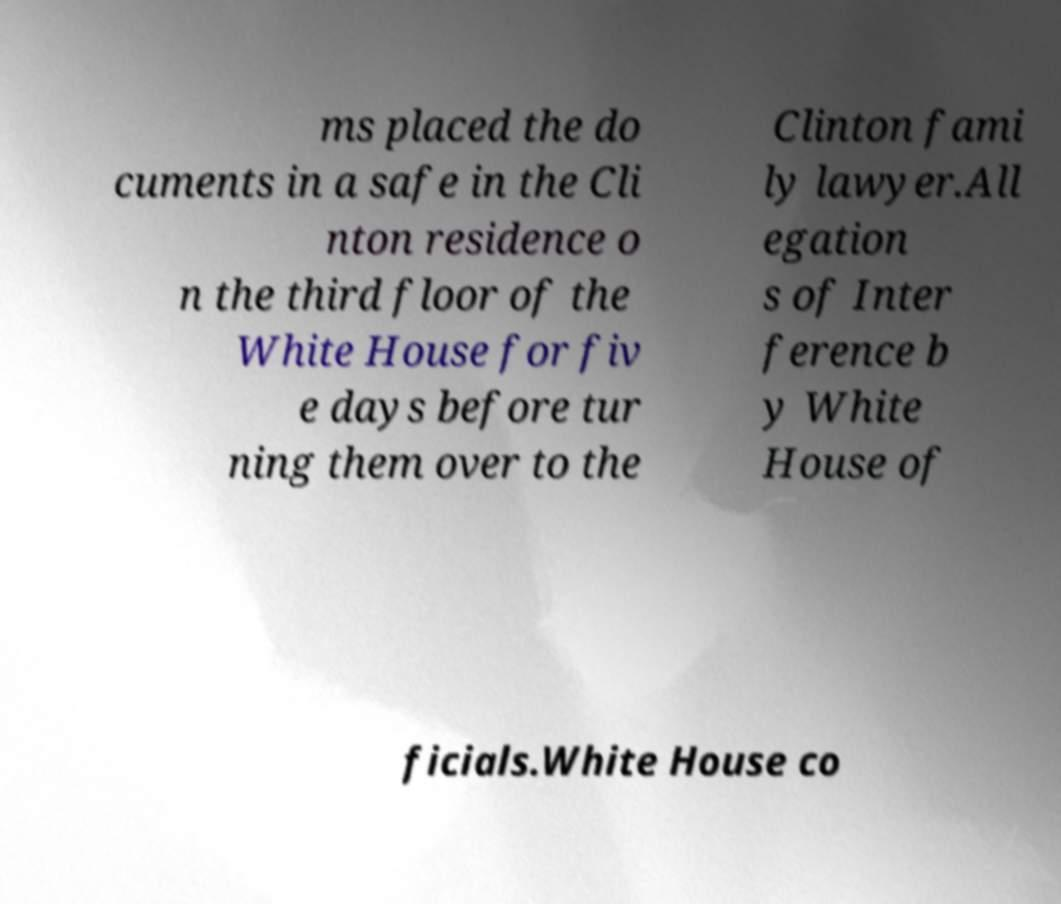What messages or text are displayed in this image? I need them in a readable, typed format. ms placed the do cuments in a safe in the Cli nton residence o n the third floor of the White House for fiv e days before tur ning them over to the Clinton fami ly lawyer.All egation s of Inter ference b y White House of ficials.White House co 